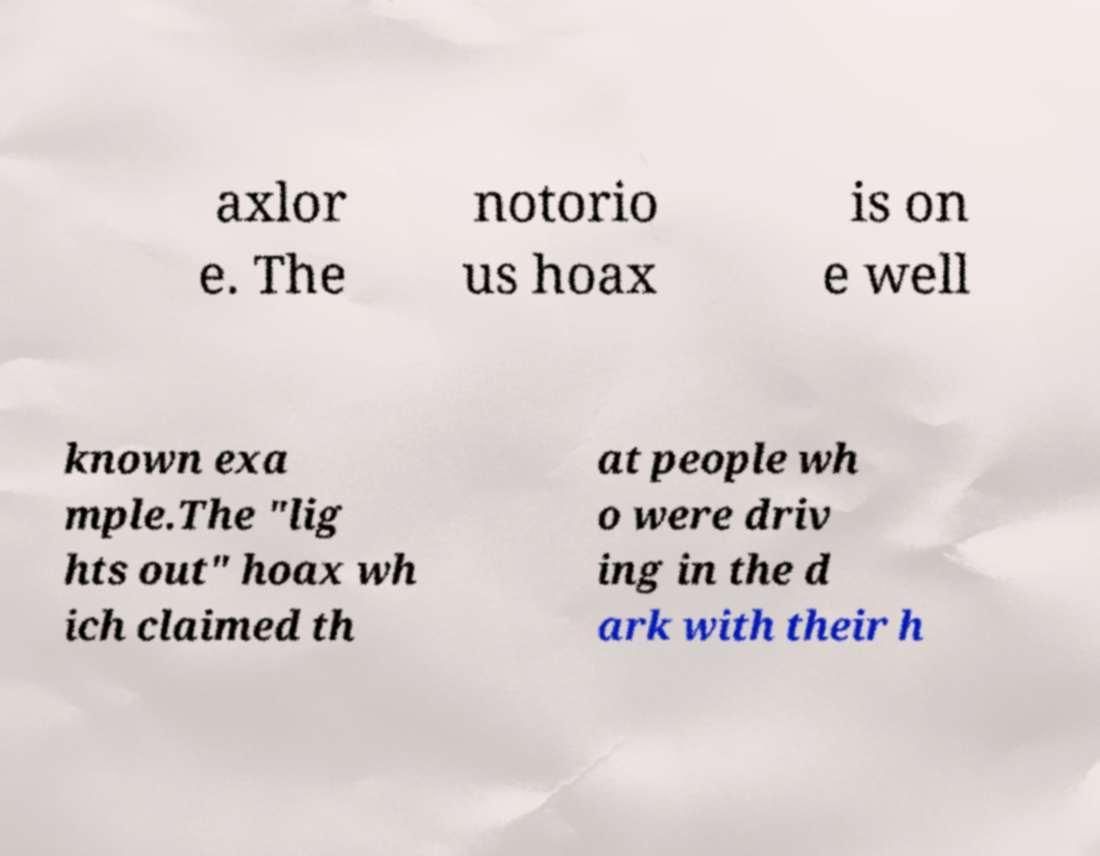Can you accurately transcribe the text from the provided image for me? axlor e. The notorio us hoax is on e well known exa mple.The "lig hts out" hoax wh ich claimed th at people wh o were driv ing in the d ark with their h 